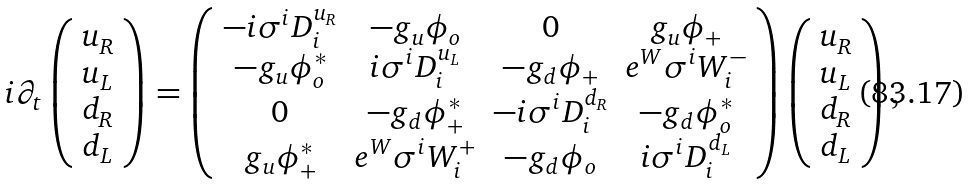<formula> <loc_0><loc_0><loc_500><loc_500>i \partial _ { t } \left ( \begin{array} { c } u _ { R } \\ u _ { L } \\ d _ { R } \\ d _ { L } \end{array} \right ) = \left ( \begin{array} { c c c c } - i \sigma ^ { i } D _ { i } ^ { u _ { R } } & - g _ { u } \phi _ { o } & 0 & g _ { u } \phi _ { + } \\ - g _ { u } \phi _ { o } ^ { * } & i \sigma ^ { i } D _ { i } ^ { u _ { L } } & - g _ { d } \phi _ { + } & e ^ { W } \sigma ^ { i } W _ { i } ^ { - } \\ 0 & - g _ { d } \phi _ { + } ^ { * } & - i \sigma ^ { i } D _ { i } ^ { d _ { R } } & - g _ { d } \phi _ { o } ^ { * } \\ g _ { u } \phi _ { + } ^ { * } & e ^ { W } \sigma ^ { i } W _ { i } ^ { + } & - g _ { d } \phi _ { o } & i \sigma ^ { i } D _ { i } ^ { d _ { L } } \end{array} \right ) \left ( \begin{array} { c } u _ { R } \\ u _ { L } \\ d _ { R } \\ d _ { L } \end{array} \right ) ,</formula> 